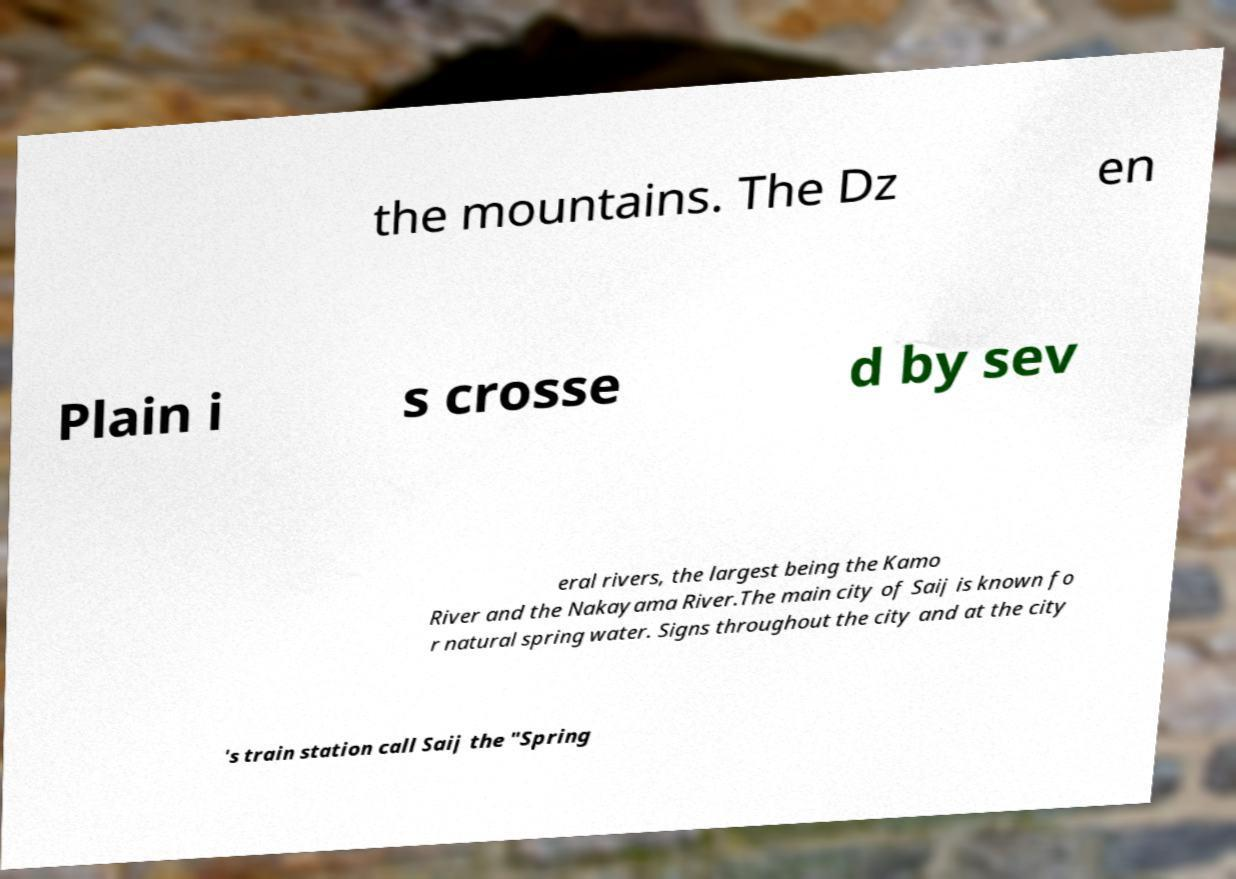What messages or text are displayed in this image? I need them in a readable, typed format. the mountains. The Dz en Plain i s crosse d by sev eral rivers, the largest being the Kamo River and the Nakayama River.The main city of Saij is known fo r natural spring water. Signs throughout the city and at the city 's train station call Saij the "Spring 